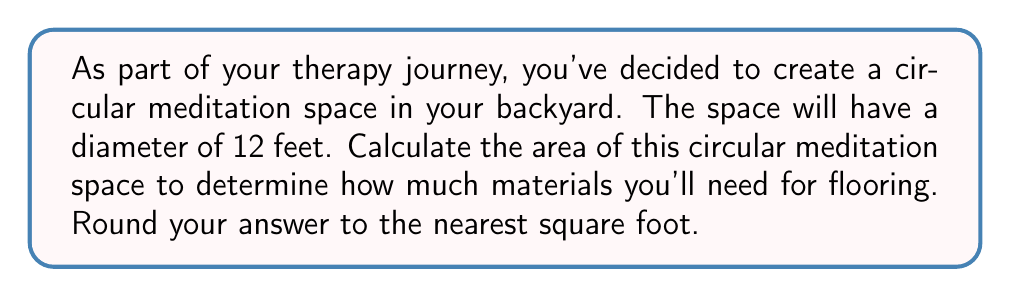Show me your answer to this math problem. To solve this problem, let's follow these steps:

1) First, recall the formula for the area of a circle:
   $$A = \pi r^2$$
   where $A$ is the area and $r$ is the radius.

2) We're given the diameter, which is 12 feet. The radius is half of the diameter:
   $$r = \frac{diameter}{2} = \frac{12}{2} = 6\text{ feet}$$

3) Now we can substitute this into our area formula:
   $$A = \pi (6)^2$$

4) Simplify:
   $$A = 36\pi\text{ square feet}$$

5) Using 3.14159 as an approximation for $\pi$:
   $$A \approx 36 * 3.14159 = 113.09724\text{ square feet}$$

6) Rounding to the nearest square foot:
   $$A \approx 113\text{ square feet}$$

[asy]
unitsize(10);
draw(circle((0,0),6));
draw((-6,0)--(6,0),dashed);
label("12 ft", (0,-6.5));
label("6 ft", (3,0), N);
[/asy]
Answer: The area of the circular meditation space is approximately 113 square feet. 